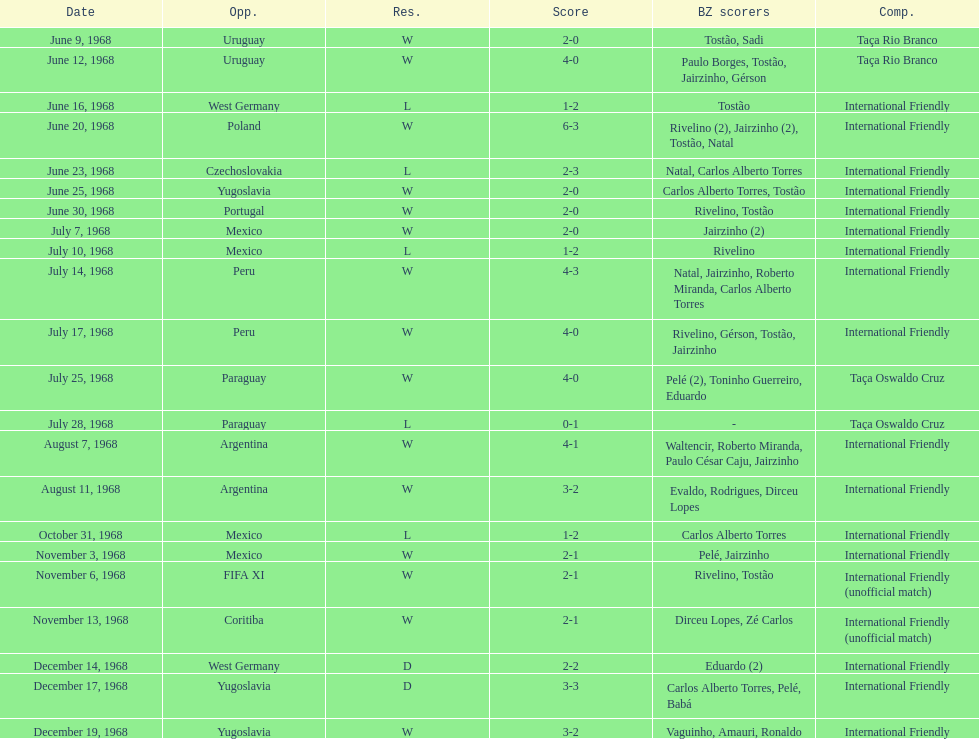Write the full table. {'header': ['Date', 'Opp.', 'Res.', 'Score', 'BZ scorers', 'Comp.'], 'rows': [['June 9, 1968', 'Uruguay', 'W', '2-0', 'Tostão, Sadi', 'Taça Rio Branco'], ['June 12, 1968', 'Uruguay', 'W', '4-0', 'Paulo Borges, Tostão, Jairzinho, Gérson', 'Taça Rio Branco'], ['June 16, 1968', 'West Germany', 'L', '1-2', 'Tostão', 'International Friendly'], ['June 20, 1968', 'Poland', 'W', '6-3', 'Rivelino (2), Jairzinho (2), Tostão, Natal', 'International Friendly'], ['June 23, 1968', 'Czechoslovakia', 'L', '2-3', 'Natal, Carlos Alberto Torres', 'International Friendly'], ['June 25, 1968', 'Yugoslavia', 'W', '2-0', 'Carlos Alberto Torres, Tostão', 'International Friendly'], ['June 30, 1968', 'Portugal', 'W', '2-0', 'Rivelino, Tostão', 'International Friendly'], ['July 7, 1968', 'Mexico', 'W', '2-0', 'Jairzinho (2)', 'International Friendly'], ['July 10, 1968', 'Mexico', 'L', '1-2', 'Rivelino', 'International Friendly'], ['July 14, 1968', 'Peru', 'W', '4-3', 'Natal, Jairzinho, Roberto Miranda, Carlos Alberto Torres', 'International Friendly'], ['July 17, 1968', 'Peru', 'W', '4-0', 'Rivelino, Gérson, Tostão, Jairzinho', 'International Friendly'], ['July 25, 1968', 'Paraguay', 'W', '4-0', 'Pelé (2), Toninho Guerreiro, Eduardo', 'Taça Oswaldo Cruz'], ['July 28, 1968', 'Paraguay', 'L', '0-1', '-', 'Taça Oswaldo Cruz'], ['August 7, 1968', 'Argentina', 'W', '4-1', 'Waltencir, Roberto Miranda, Paulo César Caju, Jairzinho', 'International Friendly'], ['August 11, 1968', 'Argentina', 'W', '3-2', 'Evaldo, Rodrigues, Dirceu Lopes', 'International Friendly'], ['October 31, 1968', 'Mexico', 'L', '1-2', 'Carlos Alberto Torres', 'International Friendly'], ['November 3, 1968', 'Mexico', 'W', '2-1', 'Pelé, Jairzinho', 'International Friendly'], ['November 6, 1968', 'FIFA XI', 'W', '2-1', 'Rivelino, Tostão', 'International Friendly (unofficial match)'], ['November 13, 1968', 'Coritiba', 'W', '2-1', 'Dirceu Lopes, Zé Carlos', 'International Friendly (unofficial match)'], ['December 14, 1968', 'West Germany', 'D', '2-2', 'Eduardo (2)', 'International Friendly'], ['December 17, 1968', 'Yugoslavia', 'D', '3-3', 'Carlos Alberto Torres, Pelé, Babá', 'International Friendly'], ['December 19, 1968', 'Yugoslavia', 'W', '3-2', 'Vaguinho, Amauri, Ronaldo', 'International Friendly']]} What is the number of countries they have played? 11. 